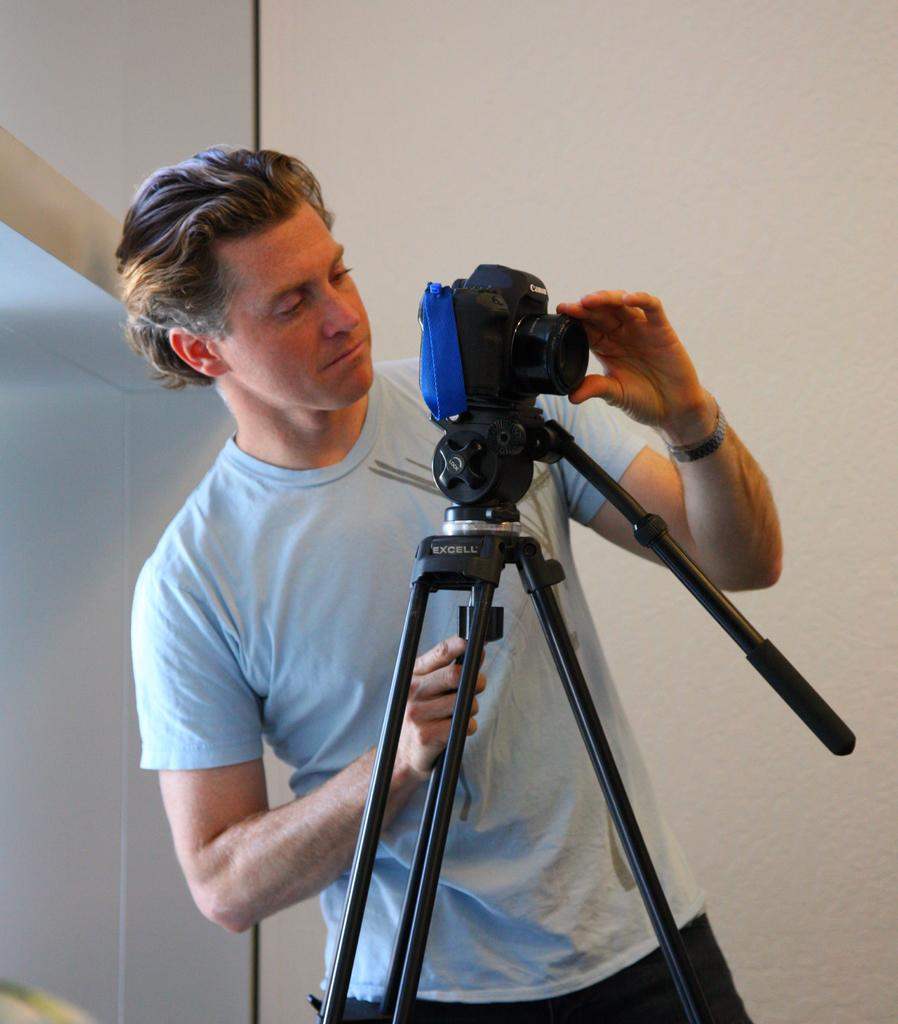Who is present in the image? There is a man in the picture. What is the man doing in the image? The man is standing in the image. What object is the man holding in the image? The man is holding a camera in the image. What can be seen in the background of the picture? There is a white wall in the background of the picture. How long does it take for the kettle to boil in the image? There is no kettle present in the image, so it is not possible to determine how long it would take for it to boil. 